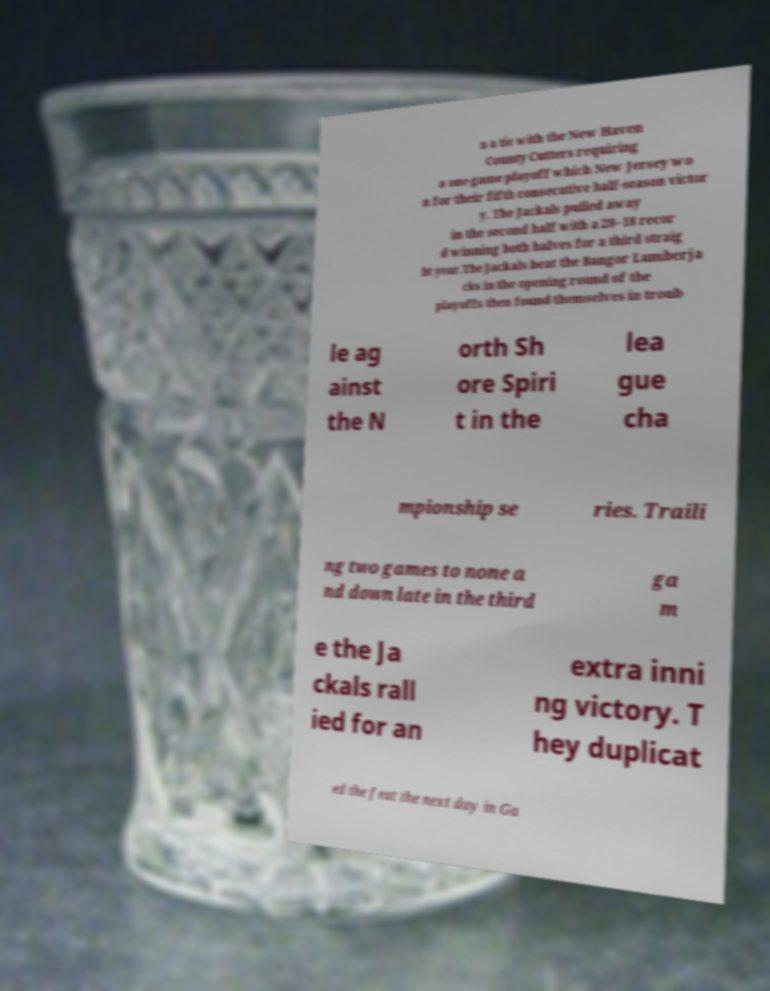Please identify and transcribe the text found in this image. n a tie with the New Haven County Cutters requiring a one-game playoff which New Jersey wo n for their fifth consecutive half-season victor y. The Jackals pulled away in the second half with a 28–18 recor d winning both halves for a third straig ht year.The Jackals beat the Bangor Lumberja cks in the opening round of the playoffs then found themselves in troub le ag ainst the N orth Sh ore Spiri t in the lea gue cha mpionship se ries. Traili ng two games to none a nd down late in the third ga m e the Ja ckals rall ied for an extra inni ng victory. T hey duplicat ed the feat the next day in Ga 